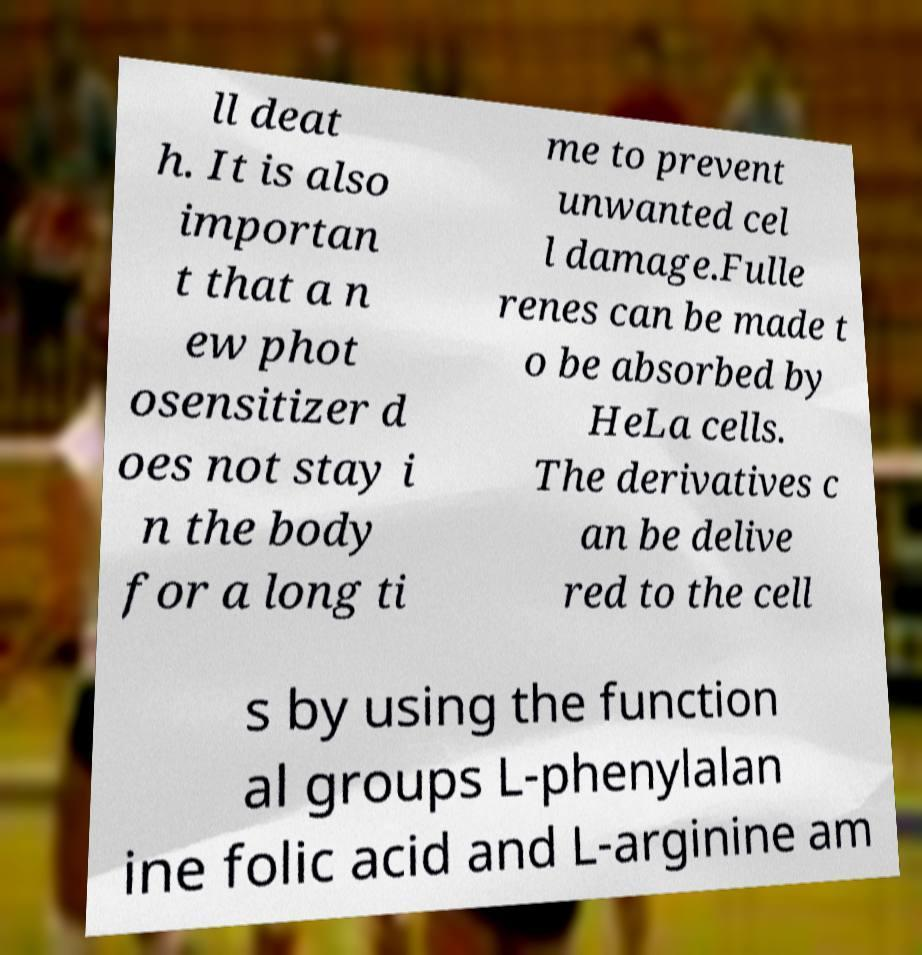Can you read and provide the text displayed in the image?This photo seems to have some interesting text. Can you extract and type it out for me? ll deat h. It is also importan t that a n ew phot osensitizer d oes not stay i n the body for a long ti me to prevent unwanted cel l damage.Fulle renes can be made t o be absorbed by HeLa cells. The derivatives c an be delive red to the cell s by using the function al groups L-phenylalan ine folic acid and L-arginine am 